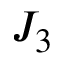Convert formula to latex. <formula><loc_0><loc_0><loc_500><loc_500>J _ { 3 }</formula> 